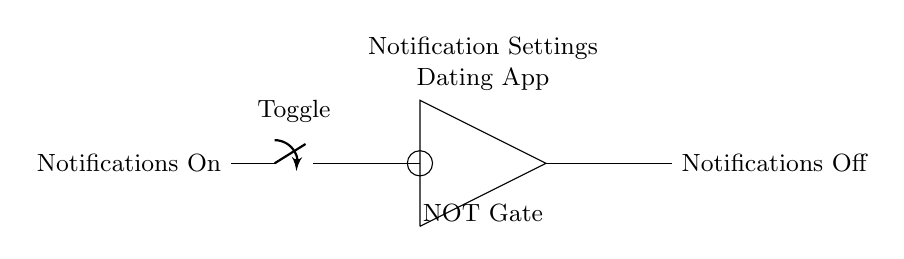What type of gate is shown in the circuit? The circuit depicts a NOT gate, identifiable by the specific symbol used in the diagram, which features a triangle with a small circle at the output. This denotes that the output is the inverse of the input.
Answer: NOT gate What component toggles the notification setting? The component responsible for toggling is the switch, located at the input. It connects or disconnects the input to the rest of the circuit, determining whether notifications are "On" or "Off".
Answer: Switch What does the output represent in this circuit? The output represents "Notifications Off", indicating the state after passing through the NOT gate where an input of "Notifications On" is toggled to its opposite.
Answer: Notifications Off What happens when the notifications are turned "On"? When the notifications are turned "On", the switch allows current to flow to the NOT gate, which will then output "Notifications Off" as it inverses the input state.
Answer: Notifications Off How many connections are there to the NOT gate? There are two connections to the NOT gate: one from the switch (input) and one leading to the output. This reflects the basic structure where the input is processed, and the output is derived.
Answer: Two connections What does the circle at the output of the NOT gate signify? The circle at the output signifies that the output is the negation or inversion of the input signal, confirming the gate's function as a NOT gate.
Answer: Inversion 